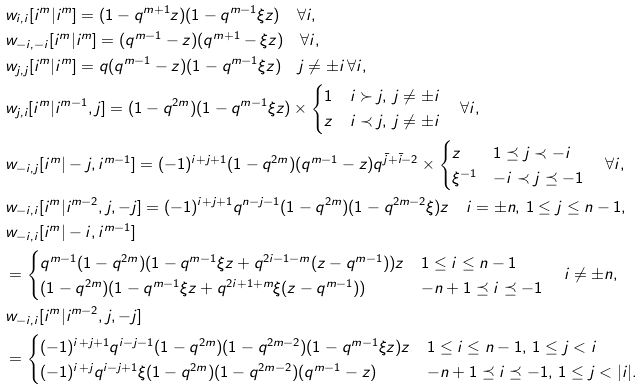Convert formula to latex. <formula><loc_0><loc_0><loc_500><loc_500>& w _ { i , i } [ i ^ { m } | i ^ { m } ] = ( 1 - q ^ { m + 1 } z ) ( 1 - q ^ { m - 1 } \xi z ) \quad \forall i , \\ & w _ { - i , - i } [ i ^ { m } | i ^ { m } ] = ( q ^ { m - 1 } - z ) ( q ^ { m + 1 } - \xi z ) \quad \forall i , \\ & w _ { j , j } [ i ^ { m } | i ^ { m } ] = q ( q ^ { m - 1 } - z ) ( 1 - q ^ { m - 1 } \xi z ) \quad j \neq \pm i \, \forall i , \\ & w _ { j , i } [ i ^ { m } | i ^ { m - 1 } , j ] = ( 1 - q ^ { 2 m } ) ( 1 - q ^ { m - 1 } \xi z ) \times \begin{cases} 1 & i \succ j , \, j \neq \pm i \\ z & i \prec j , \, j \neq \pm i \end{cases} \quad \forall i , \\ & w _ { - i , j } [ i ^ { m } | - j , i ^ { m - 1 } ] = ( - 1 ) ^ { i + j + 1 } ( 1 - q ^ { 2 m } ) ( q ^ { m - 1 } - z ) q ^ { \bar { j } + \bar { i } - 2 } \times \begin{cases} z & 1 \preceq j \prec - i \\ \xi ^ { - 1 } & - i \prec j \preceq - 1 \end{cases} \quad \forall i , \\ & w _ { - i , i } [ i ^ { m } | i ^ { m - 2 } , j , - j ] = ( - 1 ) ^ { i + j + 1 } q ^ { n - j - 1 } ( 1 - q ^ { 2 m } ) ( 1 - q ^ { 2 m - 2 } \xi ) z \quad i = \pm n , \, 1 \leq j \leq n - 1 , \\ & w _ { - i , i } [ i ^ { m } | - i , i ^ { m - 1 } ] \\ & = \begin{cases} q ^ { m - 1 } ( 1 - q ^ { 2 m } ) ( 1 - q ^ { m - 1 } \xi z + q ^ { 2 i - 1 - m } ( z - q ^ { m - 1 } ) ) z & 1 \leq i \leq n - 1 \\ ( 1 - q ^ { 2 m } ) ( 1 - q ^ { m - 1 } \xi z + q ^ { 2 i + 1 + m } \xi ( z - q ^ { m - 1 } ) ) & - n + 1 \preceq i \preceq - 1 \end{cases} \quad i \neq \pm n , \\ & w _ { - i , i } [ i ^ { m } | i ^ { m - 2 } , j , - j ] \\ & = \begin{cases} ( - 1 ) ^ { i + j + 1 } q ^ { i - j - 1 } ( 1 - q ^ { 2 m } ) ( 1 - q ^ { 2 m - 2 } ) ( 1 - q ^ { m - 1 } \xi z ) z & 1 \leq i \leq n - 1 , \, 1 \leq j < i \\ ( - 1 ) ^ { i + j } q ^ { i - j + 1 } \xi ( 1 - q ^ { 2 m } ) ( 1 - q ^ { 2 m - 2 } ) ( q ^ { m - 1 } - z ) & - n + 1 \preceq i \preceq - 1 , \, 1 \leq j < | i | . \end{cases}</formula> 